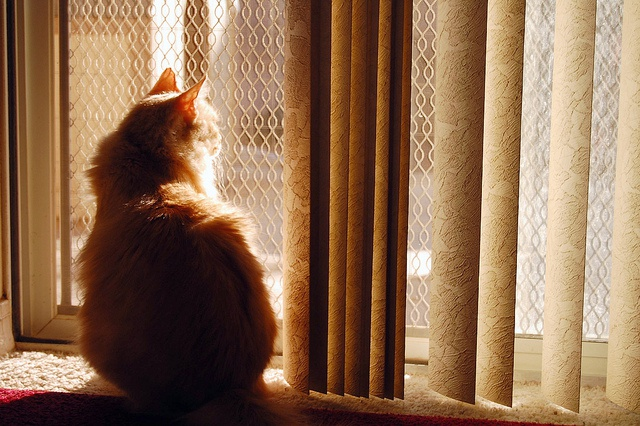Describe the objects in this image and their specific colors. I can see a cat in maroon, black, ivory, and brown tones in this image. 